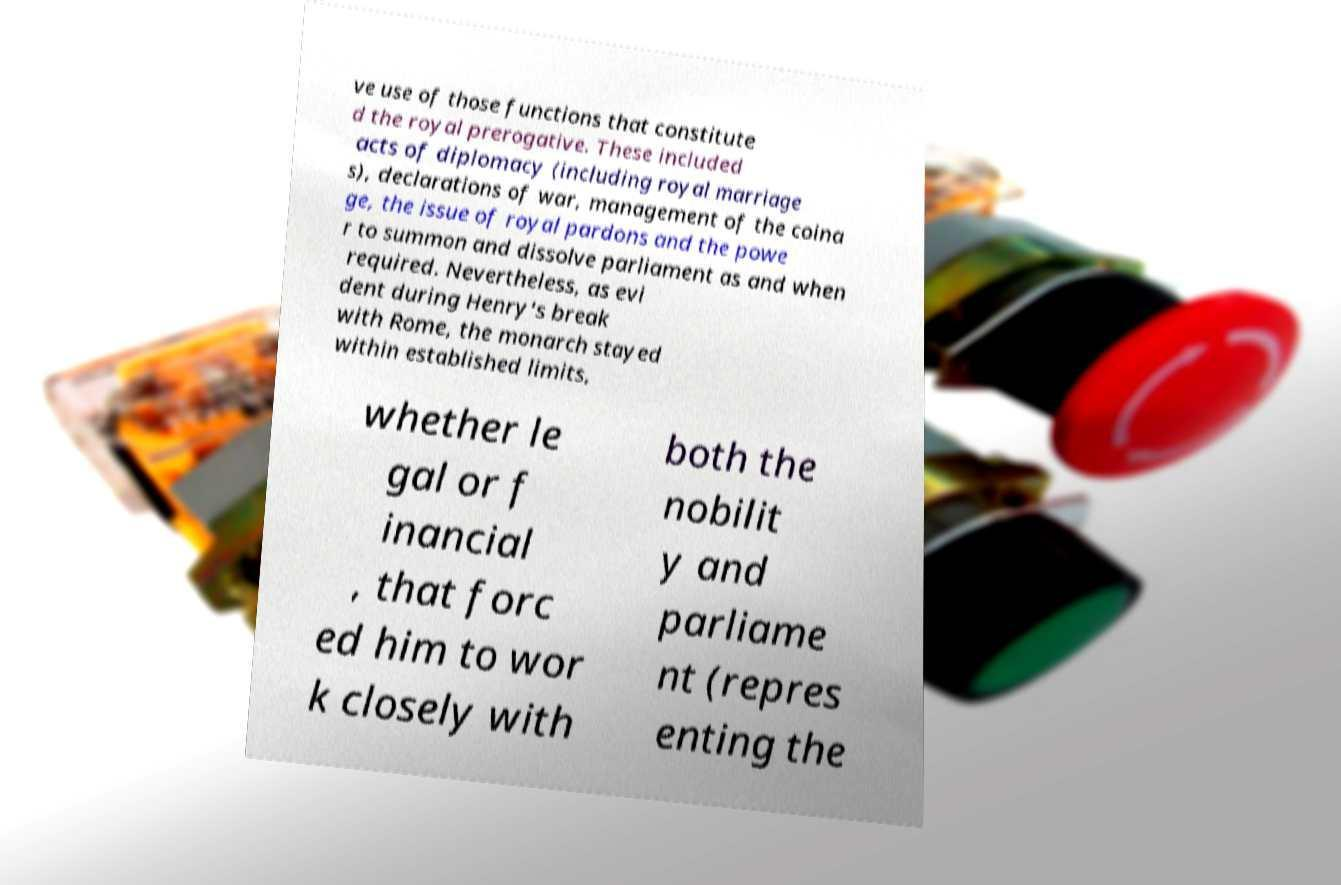Please identify and transcribe the text found in this image. ve use of those functions that constitute d the royal prerogative. These included acts of diplomacy (including royal marriage s), declarations of war, management of the coina ge, the issue of royal pardons and the powe r to summon and dissolve parliament as and when required. Nevertheless, as evi dent during Henry's break with Rome, the monarch stayed within established limits, whether le gal or f inancial , that forc ed him to wor k closely with both the nobilit y and parliame nt (repres enting the 